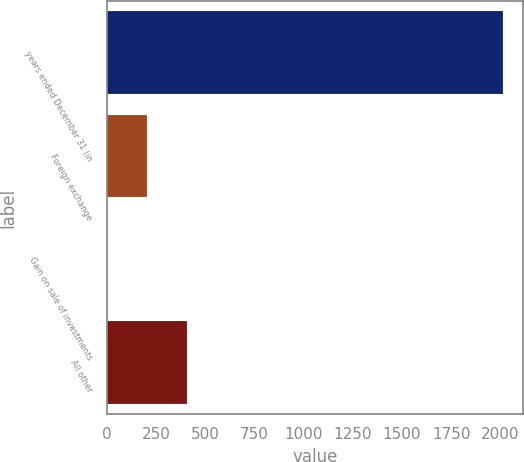Convert chart to OTSL. <chart><loc_0><loc_0><loc_500><loc_500><bar_chart><fcel>years ended December 31 (in<fcel>Foreign exchange<fcel>Gain on sale of investments<fcel>All other<nl><fcel>2016<fcel>204.3<fcel>3<fcel>405.6<nl></chart> 